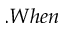Convert formula to latex. <formula><loc_0><loc_0><loc_500><loc_500>. W h e n</formula> 